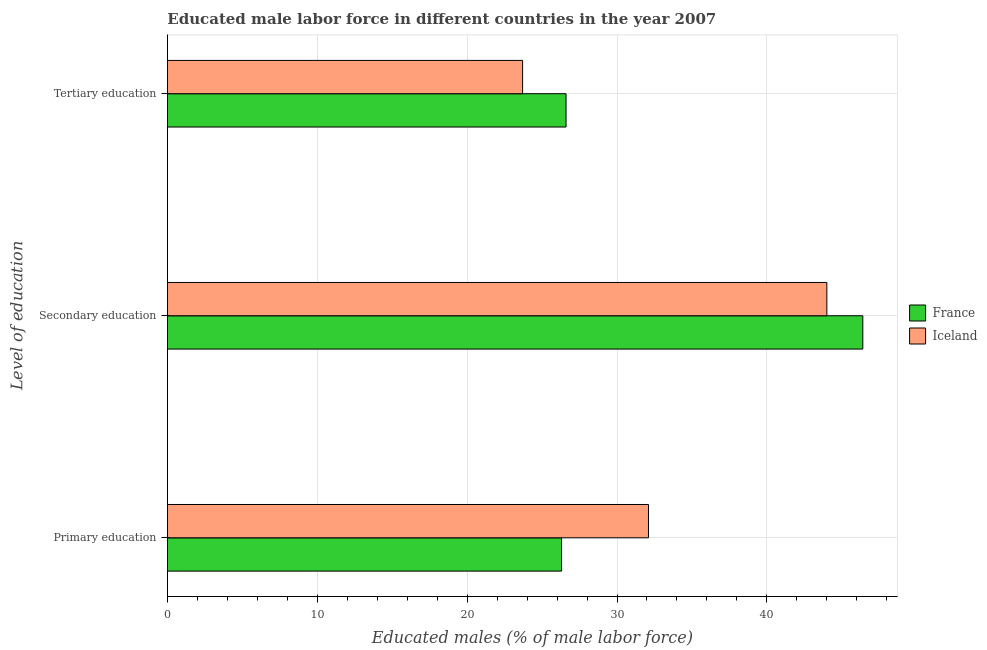How many different coloured bars are there?
Your answer should be very brief. 2. Are the number of bars on each tick of the Y-axis equal?
Ensure brevity in your answer.  Yes. What is the label of the 2nd group of bars from the top?
Make the answer very short. Secondary education. What is the percentage of male labor force who received primary education in France?
Offer a terse response. 26.3. Across all countries, what is the maximum percentage of male labor force who received tertiary education?
Give a very brief answer. 26.6. Across all countries, what is the minimum percentage of male labor force who received secondary education?
Your answer should be very brief. 44. In which country was the percentage of male labor force who received secondary education maximum?
Your response must be concise. France. What is the total percentage of male labor force who received secondary education in the graph?
Your answer should be compact. 90.4. What is the difference between the percentage of male labor force who received primary education in France and that in Iceland?
Offer a terse response. -5.8. What is the difference between the percentage of male labor force who received tertiary education in France and the percentage of male labor force who received primary education in Iceland?
Your response must be concise. -5.5. What is the average percentage of male labor force who received tertiary education per country?
Ensure brevity in your answer.  25.15. What is the difference between the percentage of male labor force who received secondary education and percentage of male labor force who received primary education in Iceland?
Ensure brevity in your answer.  11.9. In how many countries, is the percentage of male labor force who received secondary education greater than 36 %?
Your answer should be very brief. 2. What is the ratio of the percentage of male labor force who received secondary education in France to that in Iceland?
Offer a terse response. 1.05. What is the difference between the highest and the second highest percentage of male labor force who received tertiary education?
Offer a terse response. 2.9. What is the difference between the highest and the lowest percentage of male labor force who received primary education?
Offer a very short reply. 5.8. Is the sum of the percentage of male labor force who received secondary education in France and Iceland greater than the maximum percentage of male labor force who received tertiary education across all countries?
Offer a terse response. Yes. What does the 2nd bar from the top in Tertiary education represents?
Ensure brevity in your answer.  France. How many bars are there?
Your response must be concise. 6. How many countries are there in the graph?
Provide a short and direct response. 2. Does the graph contain grids?
Offer a terse response. Yes. Where does the legend appear in the graph?
Make the answer very short. Center right. How many legend labels are there?
Make the answer very short. 2. How are the legend labels stacked?
Provide a succinct answer. Vertical. What is the title of the graph?
Your answer should be very brief. Educated male labor force in different countries in the year 2007. What is the label or title of the X-axis?
Your answer should be compact. Educated males (% of male labor force). What is the label or title of the Y-axis?
Your answer should be very brief. Level of education. What is the Educated males (% of male labor force) of France in Primary education?
Your response must be concise. 26.3. What is the Educated males (% of male labor force) in Iceland in Primary education?
Your response must be concise. 32.1. What is the Educated males (% of male labor force) in France in Secondary education?
Provide a short and direct response. 46.4. What is the Educated males (% of male labor force) of Iceland in Secondary education?
Your response must be concise. 44. What is the Educated males (% of male labor force) in France in Tertiary education?
Your response must be concise. 26.6. What is the Educated males (% of male labor force) of Iceland in Tertiary education?
Give a very brief answer. 23.7. Across all Level of education, what is the maximum Educated males (% of male labor force) of France?
Your answer should be very brief. 46.4. Across all Level of education, what is the minimum Educated males (% of male labor force) in France?
Your answer should be compact. 26.3. Across all Level of education, what is the minimum Educated males (% of male labor force) in Iceland?
Keep it short and to the point. 23.7. What is the total Educated males (% of male labor force) in France in the graph?
Keep it short and to the point. 99.3. What is the total Educated males (% of male labor force) in Iceland in the graph?
Your answer should be compact. 99.8. What is the difference between the Educated males (% of male labor force) in France in Primary education and that in Secondary education?
Provide a short and direct response. -20.1. What is the difference between the Educated males (% of male labor force) of Iceland in Primary education and that in Secondary education?
Give a very brief answer. -11.9. What is the difference between the Educated males (% of male labor force) in France in Secondary education and that in Tertiary education?
Make the answer very short. 19.8. What is the difference between the Educated males (% of male labor force) in Iceland in Secondary education and that in Tertiary education?
Your response must be concise. 20.3. What is the difference between the Educated males (% of male labor force) of France in Primary education and the Educated males (% of male labor force) of Iceland in Secondary education?
Offer a terse response. -17.7. What is the difference between the Educated males (% of male labor force) in France in Secondary education and the Educated males (% of male labor force) in Iceland in Tertiary education?
Provide a short and direct response. 22.7. What is the average Educated males (% of male labor force) of France per Level of education?
Offer a very short reply. 33.1. What is the average Educated males (% of male labor force) of Iceland per Level of education?
Ensure brevity in your answer.  33.27. What is the difference between the Educated males (% of male labor force) in France and Educated males (% of male labor force) in Iceland in Primary education?
Provide a succinct answer. -5.8. What is the difference between the Educated males (% of male labor force) in France and Educated males (% of male labor force) in Iceland in Tertiary education?
Your answer should be very brief. 2.9. What is the ratio of the Educated males (% of male labor force) of France in Primary education to that in Secondary education?
Your answer should be compact. 0.57. What is the ratio of the Educated males (% of male labor force) in Iceland in Primary education to that in Secondary education?
Offer a terse response. 0.73. What is the ratio of the Educated males (% of male labor force) in France in Primary education to that in Tertiary education?
Your response must be concise. 0.99. What is the ratio of the Educated males (% of male labor force) in Iceland in Primary education to that in Tertiary education?
Make the answer very short. 1.35. What is the ratio of the Educated males (% of male labor force) of France in Secondary education to that in Tertiary education?
Your response must be concise. 1.74. What is the ratio of the Educated males (% of male labor force) in Iceland in Secondary education to that in Tertiary education?
Ensure brevity in your answer.  1.86. What is the difference between the highest and the second highest Educated males (% of male labor force) in France?
Provide a short and direct response. 19.8. What is the difference between the highest and the second highest Educated males (% of male labor force) in Iceland?
Provide a short and direct response. 11.9. What is the difference between the highest and the lowest Educated males (% of male labor force) in France?
Your response must be concise. 20.1. What is the difference between the highest and the lowest Educated males (% of male labor force) of Iceland?
Offer a very short reply. 20.3. 